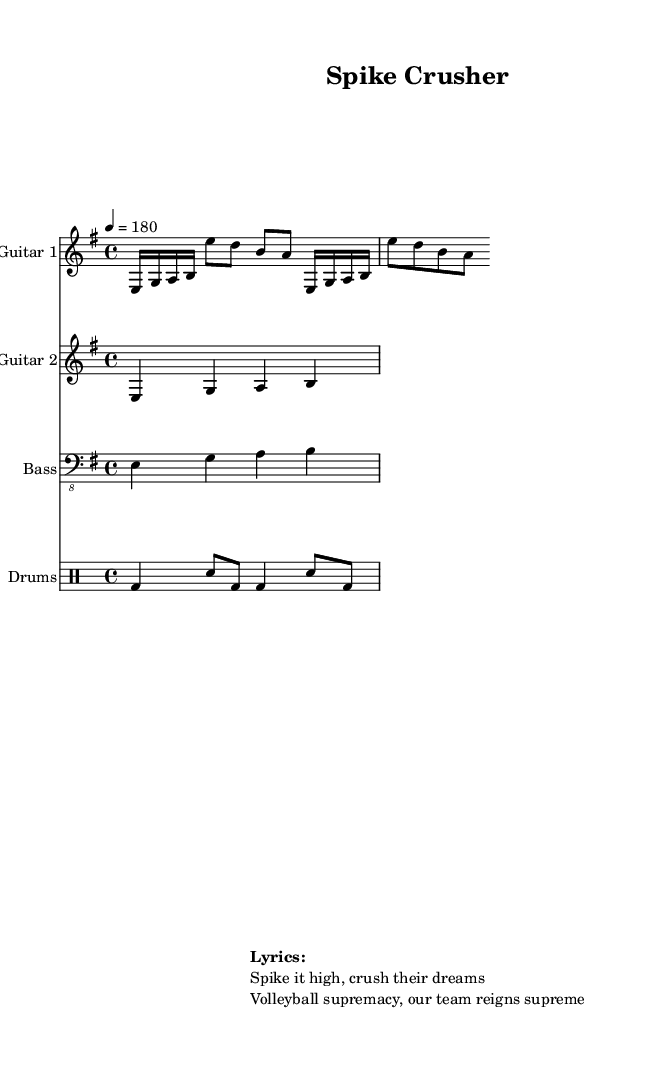What is the key signature of this music? The key signature is indicated by the "e minor" and it indicates that there is one sharp (F#) in the scale; it's shown at the beginning of the staff right after the clef.
Answer: e minor What is the time signature of this music? The time signature is located at the beginning of the score, which shows "4/4." This means there are four beats in each measure with the quarter note getting one beat.
Answer: 4/4 What is the tempo of this piece? The tempo is indicated after the time signature as "4 = 180," meaning that there are 180 quarter note beats per minute, providing a fast-paced feel typical in thrash metal.
Answer: 180 How many measures does the guitar one part contain? The guitar one part consists of a repeated section that unfolds twice, with each section containing two measures, leading to a total of four measures.
Answer: 4 What type of instrument is used in this piece? The instruments used in this piece are specified in the staff names, with "Guitar 1," "Guitar 2," "Bass," and "Drums," highlighting a typical metal band setup.
Answer: Guitar, Bass, Drums What is the overall dynamic energy expected from this track? The tempo of 180 and the fast-paced rhythm with repeated eighth notes and energetic strumming indicate a high-energy intensity typical of thrash metal, suitable for workout and pre-game warm-ups.
Answer: High-energy 